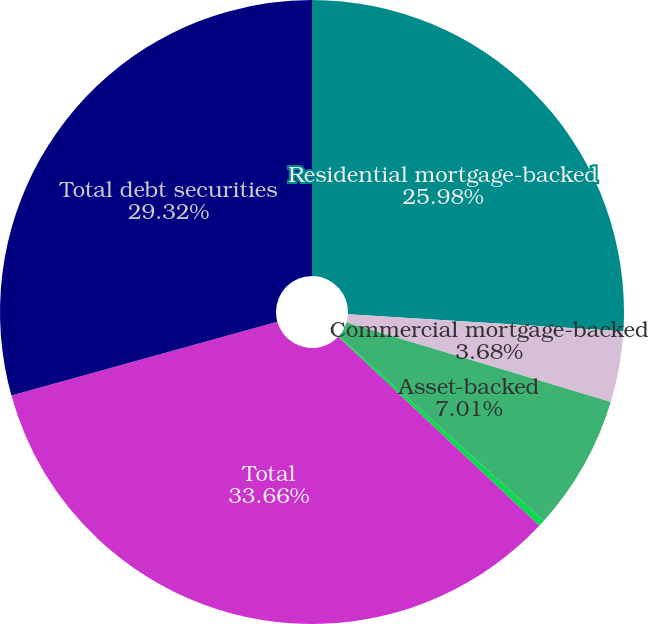<chart> <loc_0><loc_0><loc_500><loc_500><pie_chart><fcel>Residential mortgage-backed<fcel>Commercial mortgage-backed<fcel>Asset-backed<fcel>State and municipal<fcel>Total<fcel>Total debt securities<nl><fcel>25.98%<fcel>3.68%<fcel>7.01%<fcel>0.35%<fcel>33.67%<fcel>29.32%<nl></chart> 